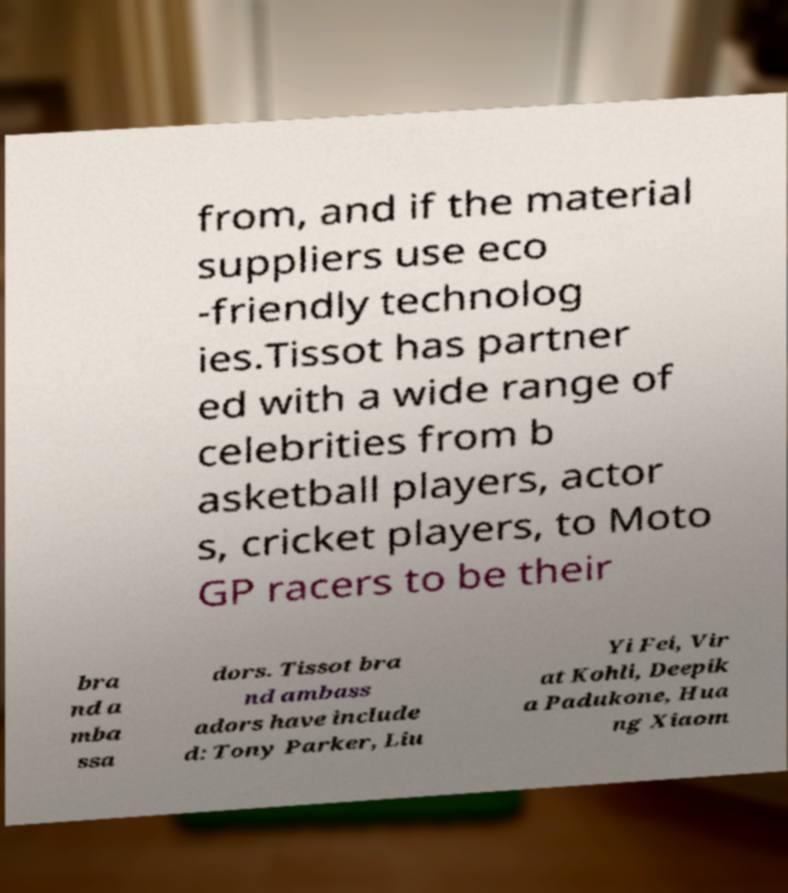Could you assist in decoding the text presented in this image and type it out clearly? from, and if the material suppliers use eco -friendly technolog ies.Tissot has partner ed with a wide range of celebrities from b asketball players, actor s, cricket players, to Moto GP racers to be their bra nd a mba ssa dors. Tissot bra nd ambass adors have include d: Tony Parker, Liu Yi Fei, Vir at Kohli, Deepik a Padukone, Hua ng Xiaom 